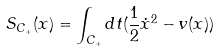<formula> <loc_0><loc_0><loc_500><loc_500>S _ { C _ { + } } ( x ) = \int _ { C _ { + } } d t ( \frac { 1 } { 2 } \dot { x } ^ { 2 } - v ( x ) )</formula> 